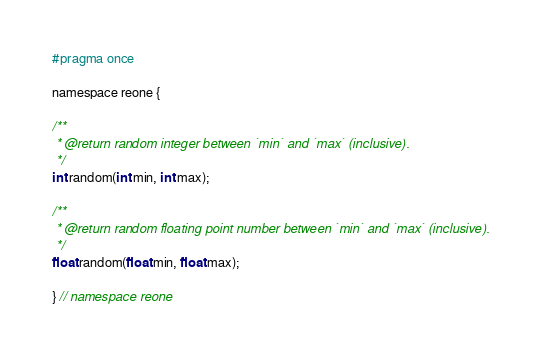<code> <loc_0><loc_0><loc_500><loc_500><_C_>#pragma once

namespace reone {

/**
 * @return random integer between `min` and `max` (inclusive).
 */
int random(int min, int max);

/**
 * @return random floating point number between `min` and `max` (inclusive).
 */
float random(float min, float max);

} // namespace reone
</code> 